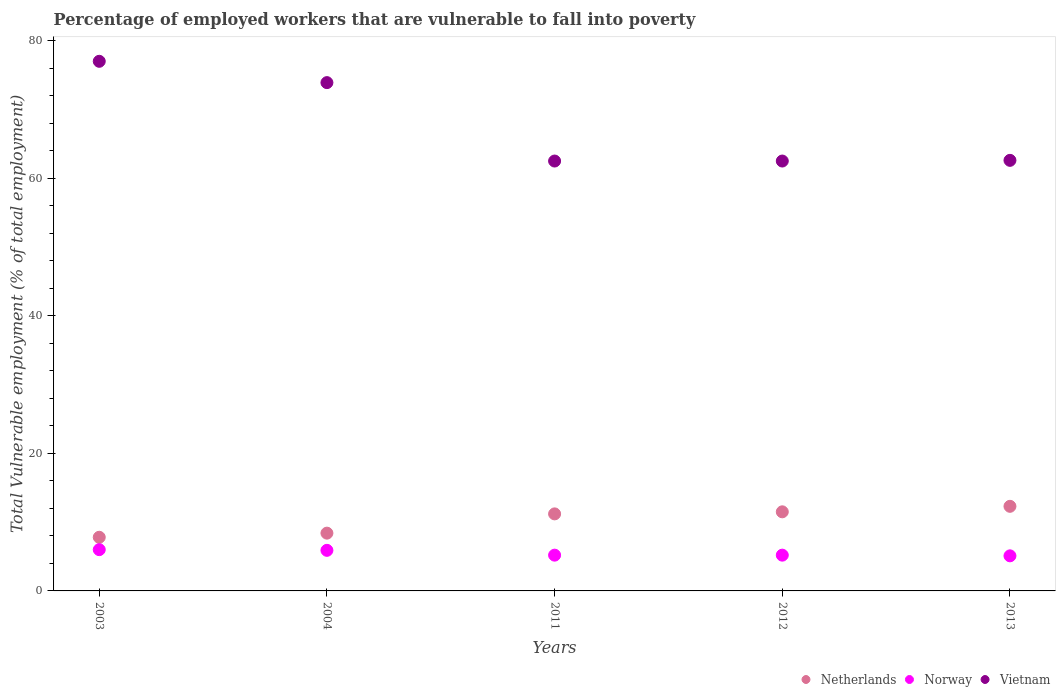How many different coloured dotlines are there?
Make the answer very short. 3. Is the number of dotlines equal to the number of legend labels?
Offer a terse response. Yes. What is the percentage of employed workers who are vulnerable to fall into poverty in Vietnam in 2012?
Provide a short and direct response. 62.5. Across all years, what is the maximum percentage of employed workers who are vulnerable to fall into poverty in Netherlands?
Provide a succinct answer. 12.3. Across all years, what is the minimum percentage of employed workers who are vulnerable to fall into poverty in Norway?
Keep it short and to the point. 5.1. In which year was the percentage of employed workers who are vulnerable to fall into poverty in Netherlands maximum?
Offer a very short reply. 2013. What is the total percentage of employed workers who are vulnerable to fall into poverty in Netherlands in the graph?
Your answer should be very brief. 51.2. What is the difference between the percentage of employed workers who are vulnerable to fall into poverty in Vietnam in 2003 and that in 2011?
Make the answer very short. 14.5. What is the difference between the percentage of employed workers who are vulnerable to fall into poverty in Norway in 2011 and the percentage of employed workers who are vulnerable to fall into poverty in Vietnam in 2003?
Give a very brief answer. -71.8. What is the average percentage of employed workers who are vulnerable to fall into poverty in Vietnam per year?
Ensure brevity in your answer.  67.7. In the year 2003, what is the difference between the percentage of employed workers who are vulnerable to fall into poverty in Norway and percentage of employed workers who are vulnerable to fall into poverty in Vietnam?
Provide a short and direct response. -71. In how many years, is the percentage of employed workers who are vulnerable to fall into poverty in Netherlands greater than 68 %?
Your response must be concise. 0. What is the ratio of the percentage of employed workers who are vulnerable to fall into poverty in Vietnam in 2012 to that in 2013?
Ensure brevity in your answer.  1. Is the percentage of employed workers who are vulnerable to fall into poverty in Norway in 2004 less than that in 2012?
Your answer should be very brief. No. What is the difference between the highest and the second highest percentage of employed workers who are vulnerable to fall into poverty in Norway?
Give a very brief answer. 0.1. What is the difference between the highest and the lowest percentage of employed workers who are vulnerable to fall into poverty in Vietnam?
Ensure brevity in your answer.  14.5. Is the sum of the percentage of employed workers who are vulnerable to fall into poverty in Norway in 2004 and 2011 greater than the maximum percentage of employed workers who are vulnerable to fall into poverty in Vietnam across all years?
Provide a succinct answer. No. Does the percentage of employed workers who are vulnerable to fall into poverty in Vietnam monotonically increase over the years?
Offer a very short reply. No. Is the percentage of employed workers who are vulnerable to fall into poverty in Norway strictly less than the percentage of employed workers who are vulnerable to fall into poverty in Netherlands over the years?
Your answer should be very brief. Yes. How many dotlines are there?
Your answer should be compact. 3. Are the values on the major ticks of Y-axis written in scientific E-notation?
Offer a terse response. No. Does the graph contain any zero values?
Offer a very short reply. No. Does the graph contain grids?
Keep it short and to the point. No. How many legend labels are there?
Make the answer very short. 3. What is the title of the graph?
Your answer should be very brief. Percentage of employed workers that are vulnerable to fall into poverty. Does "Belgium" appear as one of the legend labels in the graph?
Make the answer very short. No. What is the label or title of the Y-axis?
Make the answer very short. Total Vulnerable employment (% of total employment). What is the Total Vulnerable employment (% of total employment) of Netherlands in 2003?
Make the answer very short. 7.8. What is the Total Vulnerable employment (% of total employment) in Norway in 2003?
Your answer should be very brief. 6. What is the Total Vulnerable employment (% of total employment) in Netherlands in 2004?
Offer a terse response. 8.4. What is the Total Vulnerable employment (% of total employment) in Norway in 2004?
Offer a terse response. 5.9. What is the Total Vulnerable employment (% of total employment) in Vietnam in 2004?
Your response must be concise. 73.9. What is the Total Vulnerable employment (% of total employment) of Netherlands in 2011?
Your answer should be very brief. 11.2. What is the Total Vulnerable employment (% of total employment) of Norway in 2011?
Your answer should be compact. 5.2. What is the Total Vulnerable employment (% of total employment) in Vietnam in 2011?
Your answer should be compact. 62.5. What is the Total Vulnerable employment (% of total employment) of Netherlands in 2012?
Keep it short and to the point. 11.5. What is the Total Vulnerable employment (% of total employment) in Norway in 2012?
Ensure brevity in your answer.  5.2. What is the Total Vulnerable employment (% of total employment) of Vietnam in 2012?
Give a very brief answer. 62.5. What is the Total Vulnerable employment (% of total employment) of Netherlands in 2013?
Your answer should be compact. 12.3. What is the Total Vulnerable employment (% of total employment) of Norway in 2013?
Offer a terse response. 5.1. What is the Total Vulnerable employment (% of total employment) in Vietnam in 2013?
Provide a short and direct response. 62.6. Across all years, what is the maximum Total Vulnerable employment (% of total employment) of Netherlands?
Keep it short and to the point. 12.3. Across all years, what is the maximum Total Vulnerable employment (% of total employment) in Norway?
Make the answer very short. 6. Across all years, what is the maximum Total Vulnerable employment (% of total employment) in Vietnam?
Provide a short and direct response. 77. Across all years, what is the minimum Total Vulnerable employment (% of total employment) of Netherlands?
Provide a short and direct response. 7.8. Across all years, what is the minimum Total Vulnerable employment (% of total employment) of Norway?
Your answer should be compact. 5.1. Across all years, what is the minimum Total Vulnerable employment (% of total employment) in Vietnam?
Provide a short and direct response. 62.5. What is the total Total Vulnerable employment (% of total employment) in Netherlands in the graph?
Your response must be concise. 51.2. What is the total Total Vulnerable employment (% of total employment) of Norway in the graph?
Provide a succinct answer. 27.4. What is the total Total Vulnerable employment (% of total employment) in Vietnam in the graph?
Keep it short and to the point. 338.5. What is the difference between the Total Vulnerable employment (% of total employment) of Netherlands in 2003 and that in 2004?
Provide a succinct answer. -0.6. What is the difference between the Total Vulnerable employment (% of total employment) of Norway in 2003 and that in 2011?
Your answer should be compact. 0.8. What is the difference between the Total Vulnerable employment (% of total employment) of Netherlands in 2003 and that in 2012?
Make the answer very short. -3.7. What is the difference between the Total Vulnerable employment (% of total employment) in Netherlands in 2003 and that in 2013?
Provide a short and direct response. -4.5. What is the difference between the Total Vulnerable employment (% of total employment) of Norway in 2004 and that in 2011?
Ensure brevity in your answer.  0.7. What is the difference between the Total Vulnerable employment (% of total employment) of Netherlands in 2004 and that in 2012?
Keep it short and to the point. -3.1. What is the difference between the Total Vulnerable employment (% of total employment) in Norway in 2004 and that in 2012?
Keep it short and to the point. 0.7. What is the difference between the Total Vulnerable employment (% of total employment) of Norway in 2011 and that in 2012?
Your answer should be very brief. 0. What is the difference between the Total Vulnerable employment (% of total employment) in Vietnam in 2011 and that in 2012?
Offer a terse response. 0. What is the difference between the Total Vulnerable employment (% of total employment) in Vietnam in 2011 and that in 2013?
Keep it short and to the point. -0.1. What is the difference between the Total Vulnerable employment (% of total employment) of Vietnam in 2012 and that in 2013?
Offer a very short reply. -0.1. What is the difference between the Total Vulnerable employment (% of total employment) of Netherlands in 2003 and the Total Vulnerable employment (% of total employment) of Vietnam in 2004?
Provide a succinct answer. -66.1. What is the difference between the Total Vulnerable employment (% of total employment) in Norway in 2003 and the Total Vulnerable employment (% of total employment) in Vietnam in 2004?
Make the answer very short. -67.9. What is the difference between the Total Vulnerable employment (% of total employment) of Netherlands in 2003 and the Total Vulnerable employment (% of total employment) of Vietnam in 2011?
Keep it short and to the point. -54.7. What is the difference between the Total Vulnerable employment (% of total employment) of Norway in 2003 and the Total Vulnerable employment (% of total employment) of Vietnam in 2011?
Your response must be concise. -56.5. What is the difference between the Total Vulnerable employment (% of total employment) in Netherlands in 2003 and the Total Vulnerable employment (% of total employment) in Vietnam in 2012?
Provide a succinct answer. -54.7. What is the difference between the Total Vulnerable employment (% of total employment) of Norway in 2003 and the Total Vulnerable employment (% of total employment) of Vietnam in 2012?
Offer a very short reply. -56.5. What is the difference between the Total Vulnerable employment (% of total employment) in Netherlands in 2003 and the Total Vulnerable employment (% of total employment) in Vietnam in 2013?
Your answer should be very brief. -54.8. What is the difference between the Total Vulnerable employment (% of total employment) in Norway in 2003 and the Total Vulnerable employment (% of total employment) in Vietnam in 2013?
Offer a very short reply. -56.6. What is the difference between the Total Vulnerable employment (% of total employment) in Netherlands in 2004 and the Total Vulnerable employment (% of total employment) in Vietnam in 2011?
Ensure brevity in your answer.  -54.1. What is the difference between the Total Vulnerable employment (% of total employment) in Norway in 2004 and the Total Vulnerable employment (% of total employment) in Vietnam in 2011?
Your answer should be very brief. -56.6. What is the difference between the Total Vulnerable employment (% of total employment) in Netherlands in 2004 and the Total Vulnerable employment (% of total employment) in Norway in 2012?
Your answer should be compact. 3.2. What is the difference between the Total Vulnerable employment (% of total employment) of Netherlands in 2004 and the Total Vulnerable employment (% of total employment) of Vietnam in 2012?
Provide a short and direct response. -54.1. What is the difference between the Total Vulnerable employment (% of total employment) of Norway in 2004 and the Total Vulnerable employment (% of total employment) of Vietnam in 2012?
Keep it short and to the point. -56.6. What is the difference between the Total Vulnerable employment (% of total employment) in Netherlands in 2004 and the Total Vulnerable employment (% of total employment) in Norway in 2013?
Keep it short and to the point. 3.3. What is the difference between the Total Vulnerable employment (% of total employment) in Netherlands in 2004 and the Total Vulnerable employment (% of total employment) in Vietnam in 2013?
Give a very brief answer. -54.2. What is the difference between the Total Vulnerable employment (% of total employment) of Norway in 2004 and the Total Vulnerable employment (% of total employment) of Vietnam in 2013?
Make the answer very short. -56.7. What is the difference between the Total Vulnerable employment (% of total employment) of Netherlands in 2011 and the Total Vulnerable employment (% of total employment) of Norway in 2012?
Provide a succinct answer. 6. What is the difference between the Total Vulnerable employment (% of total employment) of Netherlands in 2011 and the Total Vulnerable employment (% of total employment) of Vietnam in 2012?
Offer a very short reply. -51.3. What is the difference between the Total Vulnerable employment (% of total employment) in Norway in 2011 and the Total Vulnerable employment (% of total employment) in Vietnam in 2012?
Provide a succinct answer. -57.3. What is the difference between the Total Vulnerable employment (% of total employment) in Netherlands in 2011 and the Total Vulnerable employment (% of total employment) in Vietnam in 2013?
Ensure brevity in your answer.  -51.4. What is the difference between the Total Vulnerable employment (% of total employment) in Norway in 2011 and the Total Vulnerable employment (% of total employment) in Vietnam in 2013?
Offer a terse response. -57.4. What is the difference between the Total Vulnerable employment (% of total employment) of Netherlands in 2012 and the Total Vulnerable employment (% of total employment) of Norway in 2013?
Offer a terse response. 6.4. What is the difference between the Total Vulnerable employment (% of total employment) in Netherlands in 2012 and the Total Vulnerable employment (% of total employment) in Vietnam in 2013?
Offer a very short reply. -51.1. What is the difference between the Total Vulnerable employment (% of total employment) of Norway in 2012 and the Total Vulnerable employment (% of total employment) of Vietnam in 2013?
Offer a terse response. -57.4. What is the average Total Vulnerable employment (% of total employment) in Netherlands per year?
Make the answer very short. 10.24. What is the average Total Vulnerable employment (% of total employment) in Norway per year?
Ensure brevity in your answer.  5.48. What is the average Total Vulnerable employment (% of total employment) of Vietnam per year?
Keep it short and to the point. 67.7. In the year 2003, what is the difference between the Total Vulnerable employment (% of total employment) in Netherlands and Total Vulnerable employment (% of total employment) in Norway?
Offer a very short reply. 1.8. In the year 2003, what is the difference between the Total Vulnerable employment (% of total employment) of Netherlands and Total Vulnerable employment (% of total employment) of Vietnam?
Ensure brevity in your answer.  -69.2. In the year 2003, what is the difference between the Total Vulnerable employment (% of total employment) of Norway and Total Vulnerable employment (% of total employment) of Vietnam?
Your response must be concise. -71. In the year 2004, what is the difference between the Total Vulnerable employment (% of total employment) in Netherlands and Total Vulnerable employment (% of total employment) in Vietnam?
Offer a terse response. -65.5. In the year 2004, what is the difference between the Total Vulnerable employment (% of total employment) in Norway and Total Vulnerable employment (% of total employment) in Vietnam?
Ensure brevity in your answer.  -68. In the year 2011, what is the difference between the Total Vulnerable employment (% of total employment) in Netherlands and Total Vulnerable employment (% of total employment) in Vietnam?
Offer a terse response. -51.3. In the year 2011, what is the difference between the Total Vulnerable employment (% of total employment) of Norway and Total Vulnerable employment (% of total employment) of Vietnam?
Your response must be concise. -57.3. In the year 2012, what is the difference between the Total Vulnerable employment (% of total employment) of Netherlands and Total Vulnerable employment (% of total employment) of Vietnam?
Provide a short and direct response. -51. In the year 2012, what is the difference between the Total Vulnerable employment (% of total employment) in Norway and Total Vulnerable employment (% of total employment) in Vietnam?
Ensure brevity in your answer.  -57.3. In the year 2013, what is the difference between the Total Vulnerable employment (% of total employment) of Netherlands and Total Vulnerable employment (% of total employment) of Vietnam?
Provide a succinct answer. -50.3. In the year 2013, what is the difference between the Total Vulnerable employment (% of total employment) of Norway and Total Vulnerable employment (% of total employment) of Vietnam?
Keep it short and to the point. -57.5. What is the ratio of the Total Vulnerable employment (% of total employment) in Norway in 2003 to that in 2004?
Keep it short and to the point. 1.02. What is the ratio of the Total Vulnerable employment (% of total employment) in Vietnam in 2003 to that in 2004?
Give a very brief answer. 1.04. What is the ratio of the Total Vulnerable employment (% of total employment) of Netherlands in 2003 to that in 2011?
Keep it short and to the point. 0.7. What is the ratio of the Total Vulnerable employment (% of total employment) of Norway in 2003 to that in 2011?
Your answer should be very brief. 1.15. What is the ratio of the Total Vulnerable employment (% of total employment) of Vietnam in 2003 to that in 2011?
Your answer should be compact. 1.23. What is the ratio of the Total Vulnerable employment (% of total employment) in Netherlands in 2003 to that in 2012?
Give a very brief answer. 0.68. What is the ratio of the Total Vulnerable employment (% of total employment) in Norway in 2003 to that in 2012?
Ensure brevity in your answer.  1.15. What is the ratio of the Total Vulnerable employment (% of total employment) in Vietnam in 2003 to that in 2012?
Provide a succinct answer. 1.23. What is the ratio of the Total Vulnerable employment (% of total employment) in Netherlands in 2003 to that in 2013?
Provide a succinct answer. 0.63. What is the ratio of the Total Vulnerable employment (% of total employment) of Norway in 2003 to that in 2013?
Offer a very short reply. 1.18. What is the ratio of the Total Vulnerable employment (% of total employment) in Vietnam in 2003 to that in 2013?
Give a very brief answer. 1.23. What is the ratio of the Total Vulnerable employment (% of total employment) of Norway in 2004 to that in 2011?
Your response must be concise. 1.13. What is the ratio of the Total Vulnerable employment (% of total employment) of Vietnam in 2004 to that in 2011?
Offer a terse response. 1.18. What is the ratio of the Total Vulnerable employment (% of total employment) of Netherlands in 2004 to that in 2012?
Your answer should be compact. 0.73. What is the ratio of the Total Vulnerable employment (% of total employment) of Norway in 2004 to that in 2012?
Offer a terse response. 1.13. What is the ratio of the Total Vulnerable employment (% of total employment) of Vietnam in 2004 to that in 2012?
Offer a terse response. 1.18. What is the ratio of the Total Vulnerable employment (% of total employment) of Netherlands in 2004 to that in 2013?
Ensure brevity in your answer.  0.68. What is the ratio of the Total Vulnerable employment (% of total employment) of Norway in 2004 to that in 2013?
Provide a short and direct response. 1.16. What is the ratio of the Total Vulnerable employment (% of total employment) of Vietnam in 2004 to that in 2013?
Give a very brief answer. 1.18. What is the ratio of the Total Vulnerable employment (% of total employment) in Netherlands in 2011 to that in 2012?
Make the answer very short. 0.97. What is the ratio of the Total Vulnerable employment (% of total employment) of Norway in 2011 to that in 2012?
Your answer should be compact. 1. What is the ratio of the Total Vulnerable employment (% of total employment) in Netherlands in 2011 to that in 2013?
Provide a succinct answer. 0.91. What is the ratio of the Total Vulnerable employment (% of total employment) of Norway in 2011 to that in 2013?
Keep it short and to the point. 1.02. What is the ratio of the Total Vulnerable employment (% of total employment) in Netherlands in 2012 to that in 2013?
Provide a succinct answer. 0.94. What is the ratio of the Total Vulnerable employment (% of total employment) in Norway in 2012 to that in 2013?
Your answer should be very brief. 1.02. What is the difference between the highest and the second highest Total Vulnerable employment (% of total employment) of Netherlands?
Provide a succinct answer. 0.8. What is the difference between the highest and the lowest Total Vulnerable employment (% of total employment) of Netherlands?
Provide a succinct answer. 4.5. What is the difference between the highest and the lowest Total Vulnerable employment (% of total employment) of Vietnam?
Offer a terse response. 14.5. 